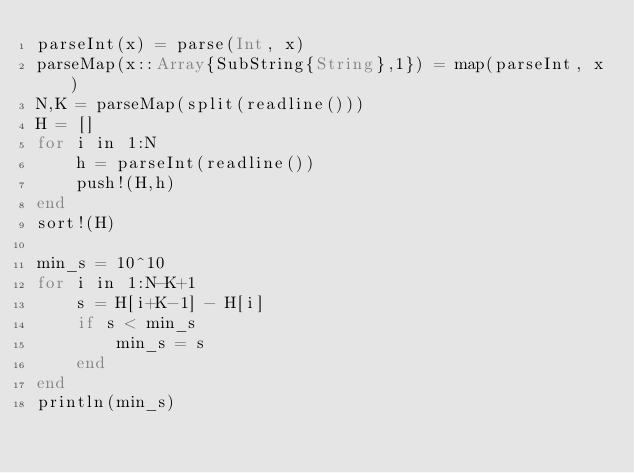<code> <loc_0><loc_0><loc_500><loc_500><_Julia_>parseInt(x) = parse(Int, x)
parseMap(x::Array{SubString{String},1}) = map(parseInt, x)
N,K = parseMap(split(readline()))
H = []
for i in 1:N 
    h = parseInt(readline())
    push!(H,h)
end
sort!(H)

min_s = 10^10
for i in 1:N-K+1
    s = H[i+K-1] - H[i]
    if s < min_s
        min_s = s
    end
end        
println(min_s)</code> 